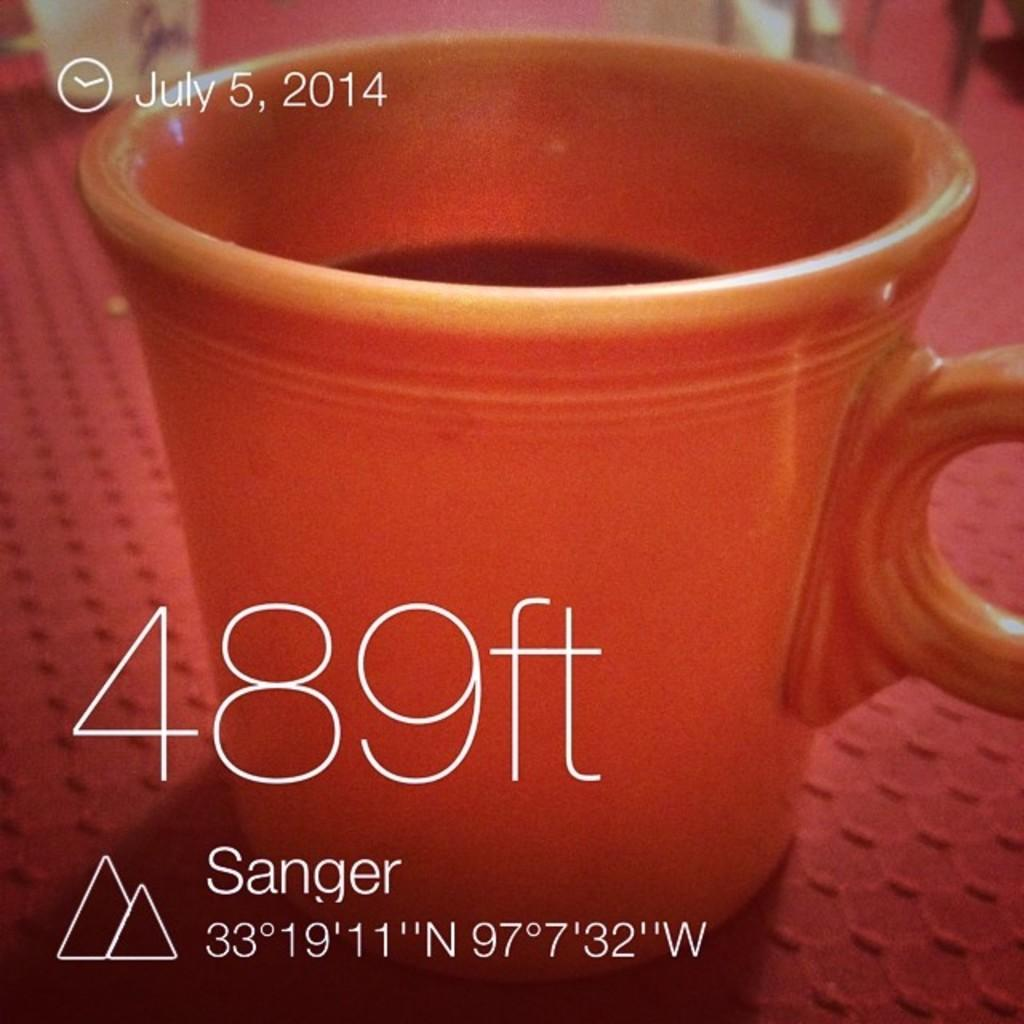<image>
Relay a brief, clear account of the picture shown. A screen has a picture of a coffee mug and says that today is July 5th. 